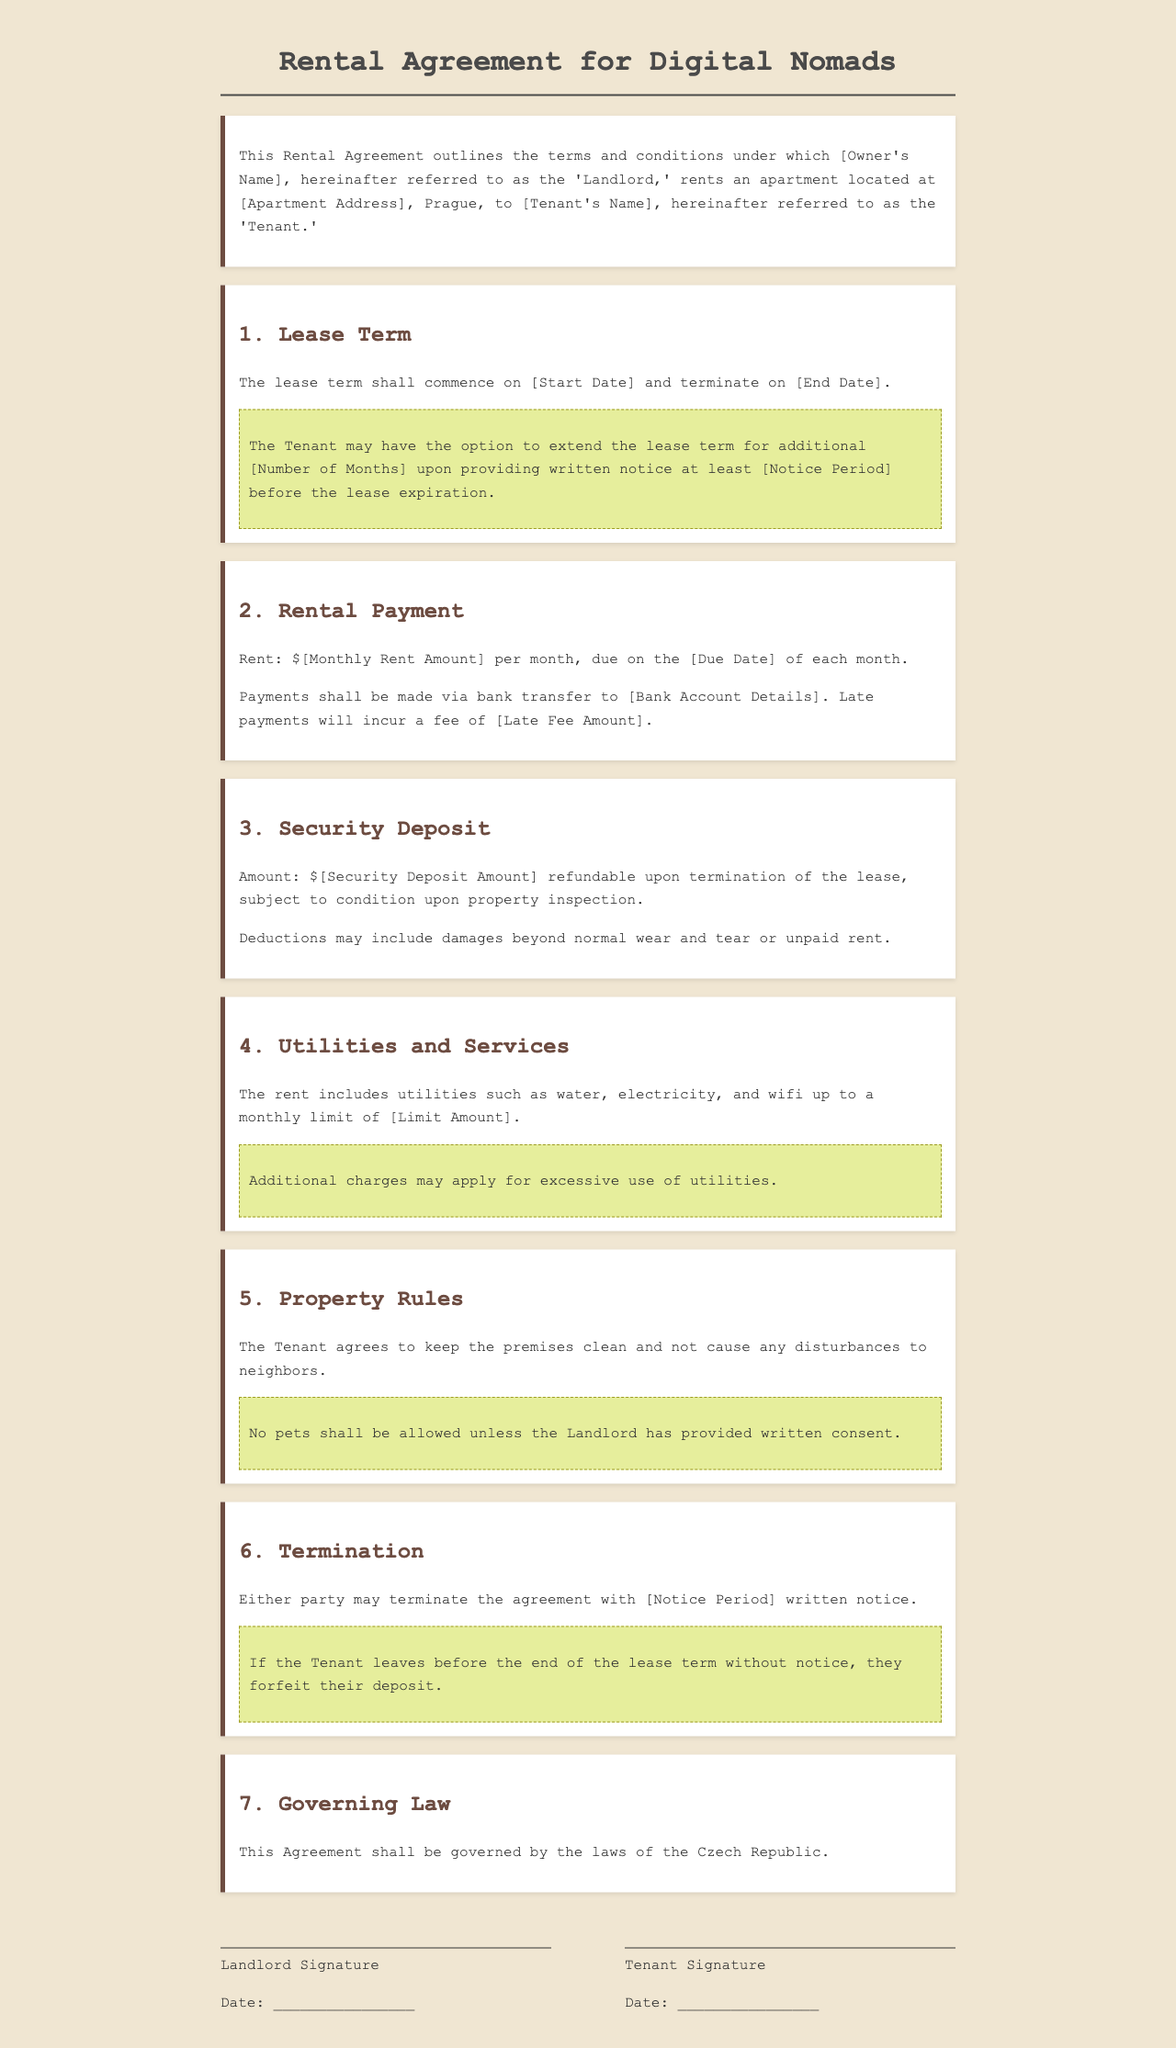What is the address of the rental property? The document specifies the rental property address as [Apartment Address].
Answer: [Apartment Address] What is the monthly rent amount? The monthly rent amount is mentioned as $[Monthly Rent Amount].
Answer: $[Monthly Rent Amount] What is the duration of the rental lease? The lease duration can be inferred from [Start Date] to [End Date].
Answer: [Start Date] to [End Date] What is the notice period for terminating the agreement? The document states that the notice period is [Notice Period].
Answer: [Notice Period] What is the amount of the security deposit? The security deposit amount is indicated as $[Security Deposit Amount].
Answer: $[Security Deposit Amount] How are late payments treated in this agreement? Late payments incur a fee of [Late Fee Amount] as mentioned in the rental payment section.
Answer: [Late Fee Amount] What are tenants reminded about utility usage? The document notes that additional charges may apply for excessive use of utilities.
Answer: Additional charges may apply Are pets allowed in the property? The agreement specifies that no pets shall be allowed unless written consent is provided by the landlord.
Answer: No pets without consent What law governs this rental agreement? The governing law stated in the agreement is the laws of the Czech Republic.
Answer: Laws of the Czech Republic 